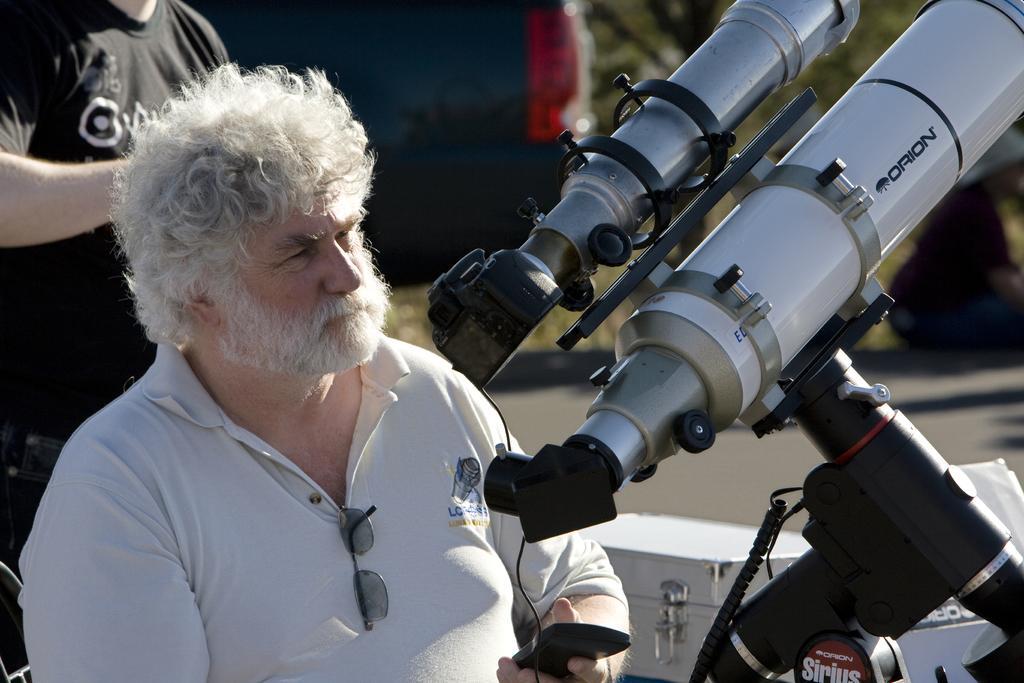How would you summarize this image in a sentence or two? In this image, on the left there is a man, he wears a t shirt. On the right there is a camera, stand, cables. In the background there are people, vehicle, boxes, road, plants. 